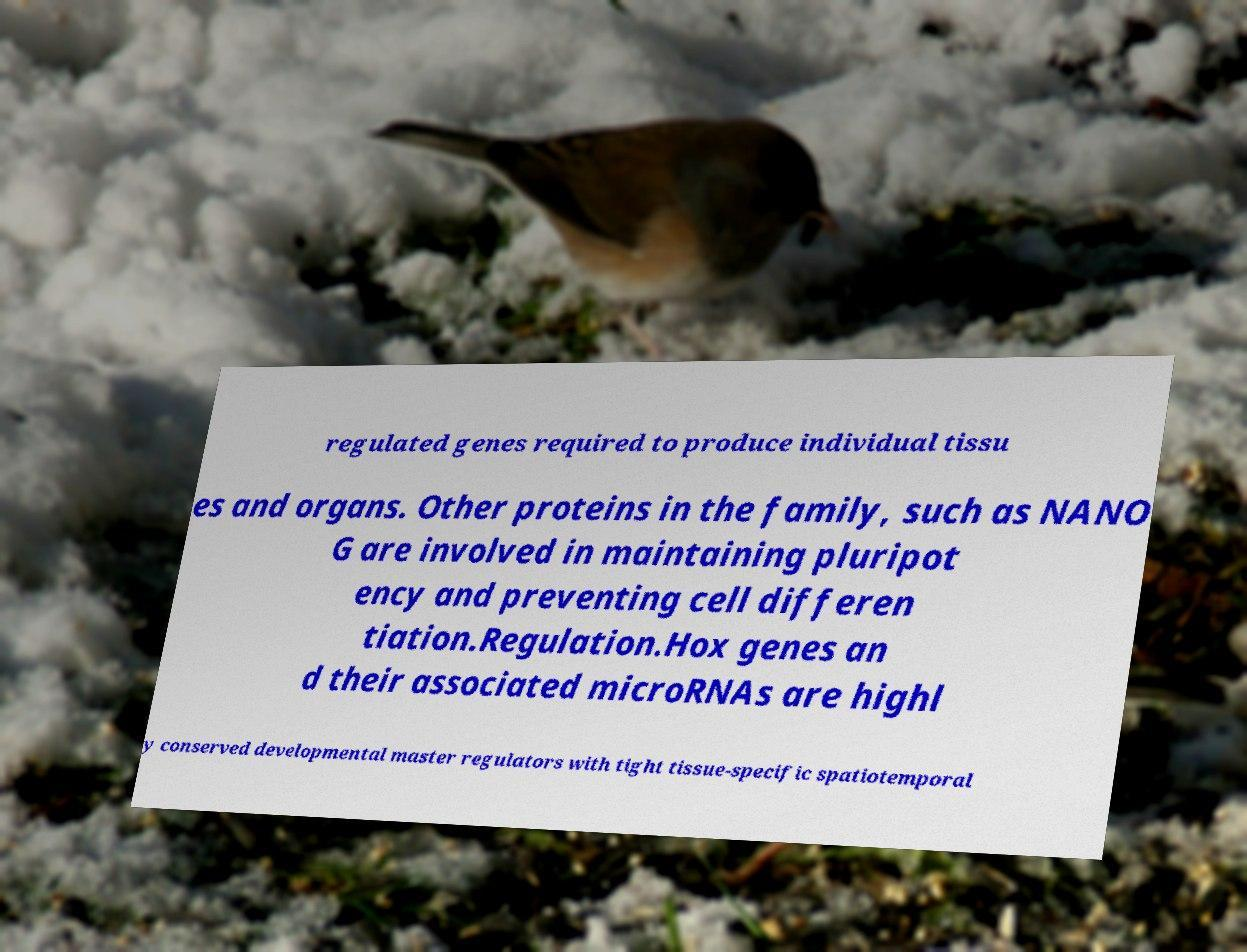Could you assist in decoding the text presented in this image and type it out clearly? regulated genes required to produce individual tissu es and organs. Other proteins in the family, such as NANO G are involved in maintaining pluripot ency and preventing cell differen tiation.Regulation.Hox genes an d their associated microRNAs are highl y conserved developmental master regulators with tight tissue-specific spatiotemporal 